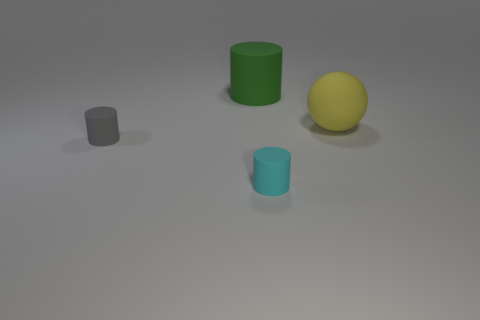There is a rubber object that is both behind the gray matte thing and in front of the large green matte object; what size is it?
Provide a short and direct response. Large. What number of cyan balls are there?
Give a very brief answer. 0. There is a gray thing that is the same size as the cyan matte cylinder; what is it made of?
Your answer should be very brief. Rubber. Is there a rubber cylinder of the same size as the yellow ball?
Ensure brevity in your answer.  Yes. Is the color of the small matte thing in front of the small gray matte object the same as the big rubber thing on the left side of the large yellow matte ball?
Provide a short and direct response. No. What number of matte objects are either tiny things or gray cylinders?
Make the answer very short. 2. How many small cylinders are to the left of the small rubber cylinder that is right of the small cylinder left of the tiny cyan rubber thing?
Make the answer very short. 1. There is a green cylinder that is the same material as the yellow object; what is its size?
Your answer should be very brief. Large. There is a thing on the right side of the cyan thing; is it the same size as the green rubber cylinder?
Provide a succinct answer. Yes. What color is the rubber object that is both behind the tiny gray rubber cylinder and to the left of the cyan thing?
Make the answer very short. Green. 